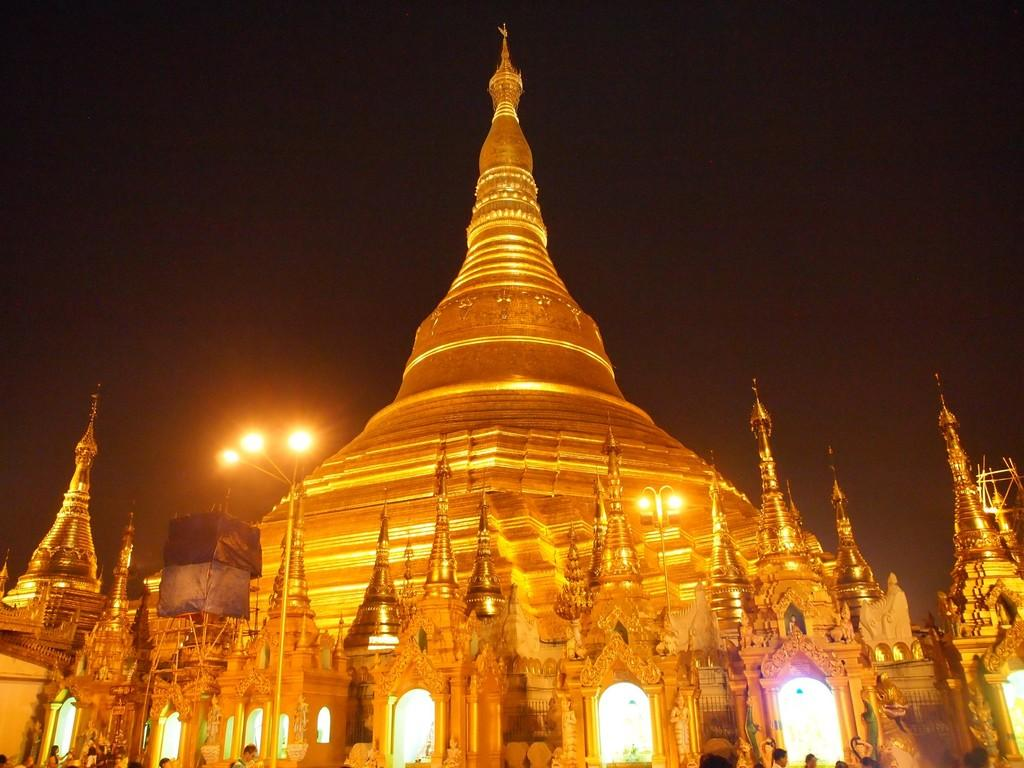What is the main subject of the image? There is a monument in the image. What is happening in front of the monument? There are people in front of the monument. Are there any other structures or objects visible in the image? Yes, there are lamp posts in the image. What type of street is visible in the image? There is no street visible in the image; it only shows a monument, people, and lamp posts. Can you tell me how many beetles are crawling on the monument in the image? There are no beetles present on the monument in the image. 